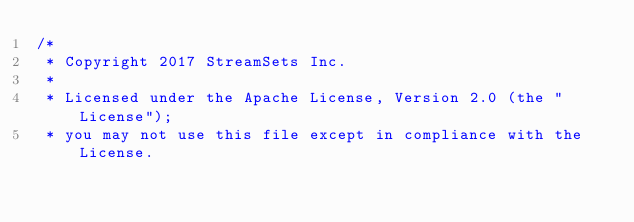Convert code to text. <code><loc_0><loc_0><loc_500><loc_500><_Java_>/*
 * Copyright 2017 StreamSets Inc.
 *
 * Licensed under the Apache License, Version 2.0 (the "License");
 * you may not use this file except in compliance with the License.</code> 